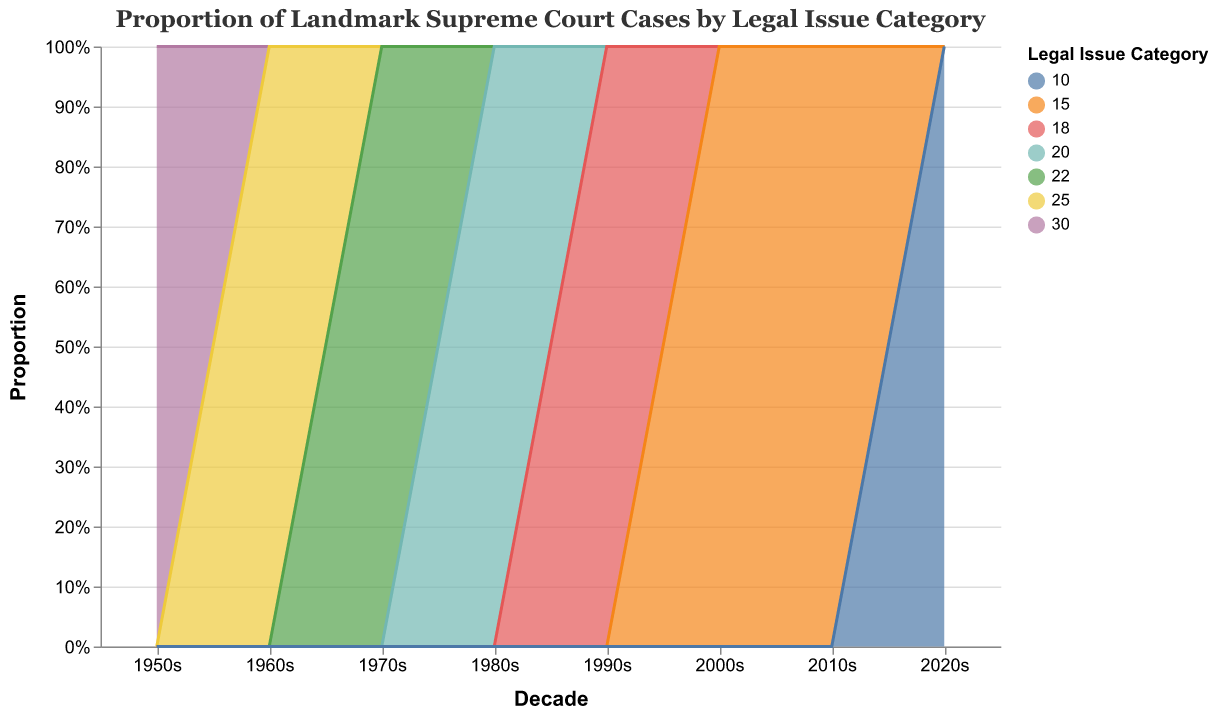What is the title of the chart? The title appears at the top of the chart. By looking at the visual, we can see the text displayed as the title.
Answer: Proportion of Landmark Supreme Court Cases by Legal Issue Category Which legal issue category had the highest proportion of cases in the 2020s? To determine this, look at the 2020s segment of the stacked area chart and find the category with the largest area.
Answer: Environmental Law How did the proportion of cases related to Civil Rights change from the 1950s to the 1960s? Observe the height of the Civil Rights area in the 1950s and compare it with the height in the 1960s. The chart indicates proportions, showing that Civil Rights increased from 20% to 30%.
Answer: Increased by 10% Which decade had the smallest proportion of Constitutional Law cases? Identify the smallest area corresponding to Constitutional Law across all decades. The 2020s show the lowest contribution with a proportion of 10%.
Answer: 2020s Compare the proportions of Criminal Law cases between the 1990s and the 2000s. Which decade had the higher proportion? Look at the height of the area representing Criminal Law for both the 1990s and the 2000s. Criminal Law cases have a larger area in the 1990s (35%) compared to the 2000s (28%).
Answer: 1990s By how much did the proportion of Environmental Law cases increase from the 1950s to the 2020s? First, find the proportion of Environmental Law cases in the 1950s (5%) and the 2020s (25%). The increase is the difference between these two values.
Answer: Increased by 20% Which category stayed relatively constant in proportion over the decades? Examine each category's area over the decades. Immigration Law's area remains small and fairly constant, from 2% in the 1950s to 6% in the 2020s.
Answer: Immigration Law In which decade did Family Law cases begin to noticeably increase? Compare the areas assigned to Family Law in each decade. Family Law started to see a noticeable increase from the 1990s onward.
Answer: 1990s How does the proportion of Economic Regulation cases in the 1970s compare to that in the 2010s? Identify the areas for Economic Regulation in both the 1970s and the 2010s. The 1970s had 18% while the 2010s had 12%.
Answer: Higher in the 1970s Which legal issue category had the largest decline in proportion between the 1960s and the 1980s? Measure the difference in the height of areas for each category between the 1960s and 1980s. Civil Rights had the largest decline, falling from 30% to 15%.
Answer: Civil Rights 